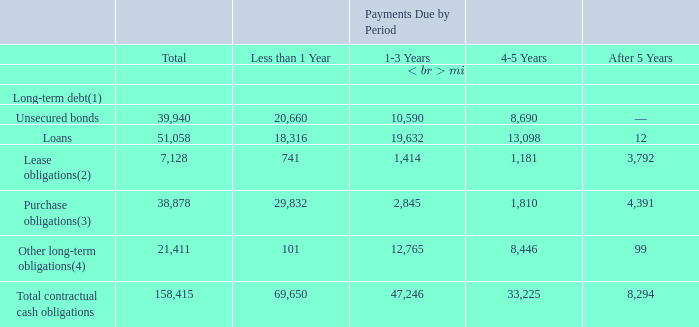F. Tabular Disclosure of Contractual Obligations
The following table sets forth our contractual obligations and commitments with definitive payment terms on a consolidated basis which will require significant cash outlays in the future as of December 31, 2019.
(1) Assuming the domestic bonds are paid off upon maturity.
(2) Represents our obligations to make lease payments mainly to use machineries, equipment, office and land on which our fabs are located, primarily in the Hsinchu Science Park and the Tainan Science Park in Taiwan, Pasir Ris Wafer Fab Park in Singapore.
(3) Represents commitments for purchase of raw materials and construction contracts, intellectual properties and royalties payable under our technology license agreements. These commitments include the amounts which are not recorded on our balance sheet as of December 31, 2019.
(4) Represents the guarantee deposits and financial liability for the repurchase of other investors’ investment. The amounts of payments due under these agreements are determined based on fixed contract amounts.
What are the obligations to make lease payments? Obligations to make lease payments mainly to use machineries, equipment, office and land on which our fabs are located. What is average of loans?
Answer scale should be: million. 51,058 / 4
Answer: 12764.5. What is the average lease obligation for the period Less than 1 Year and 1-3 Years?
Answer scale should be: million. (741+1,414) / 2
Answer: 1077.5. What is the average of total contractual cash obligations?
Answer scale should be: million. 158,415 / 4
Answer: 39603.75. What does Purchase obligations incorporate? Represents commitments for purchase of raw materials and construction contracts, intellectual properties and royalties payable under our technology license agreements. What does other long-term obligation include? Represents the guarantee deposits and financial liability for the repurchase of other investors’ investment. 